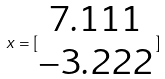Convert formula to latex. <formula><loc_0><loc_0><loc_500><loc_500>x = [ \begin{matrix} 7 . 1 1 1 \\ - 3 . 2 2 2 \end{matrix} ]</formula> 